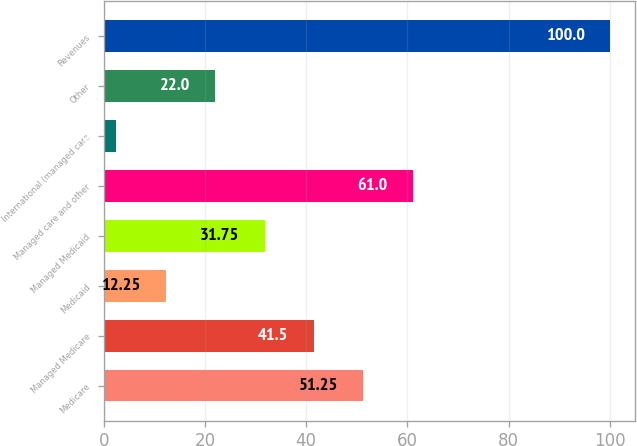Convert chart. <chart><loc_0><loc_0><loc_500><loc_500><bar_chart><fcel>Medicare<fcel>Managed Medicare<fcel>Medicaid<fcel>Managed Medicaid<fcel>Managed care and other<fcel>International (managed care<fcel>Other<fcel>Revenues<nl><fcel>51.25<fcel>41.5<fcel>12.25<fcel>31.75<fcel>61<fcel>2.5<fcel>22<fcel>100<nl></chart> 